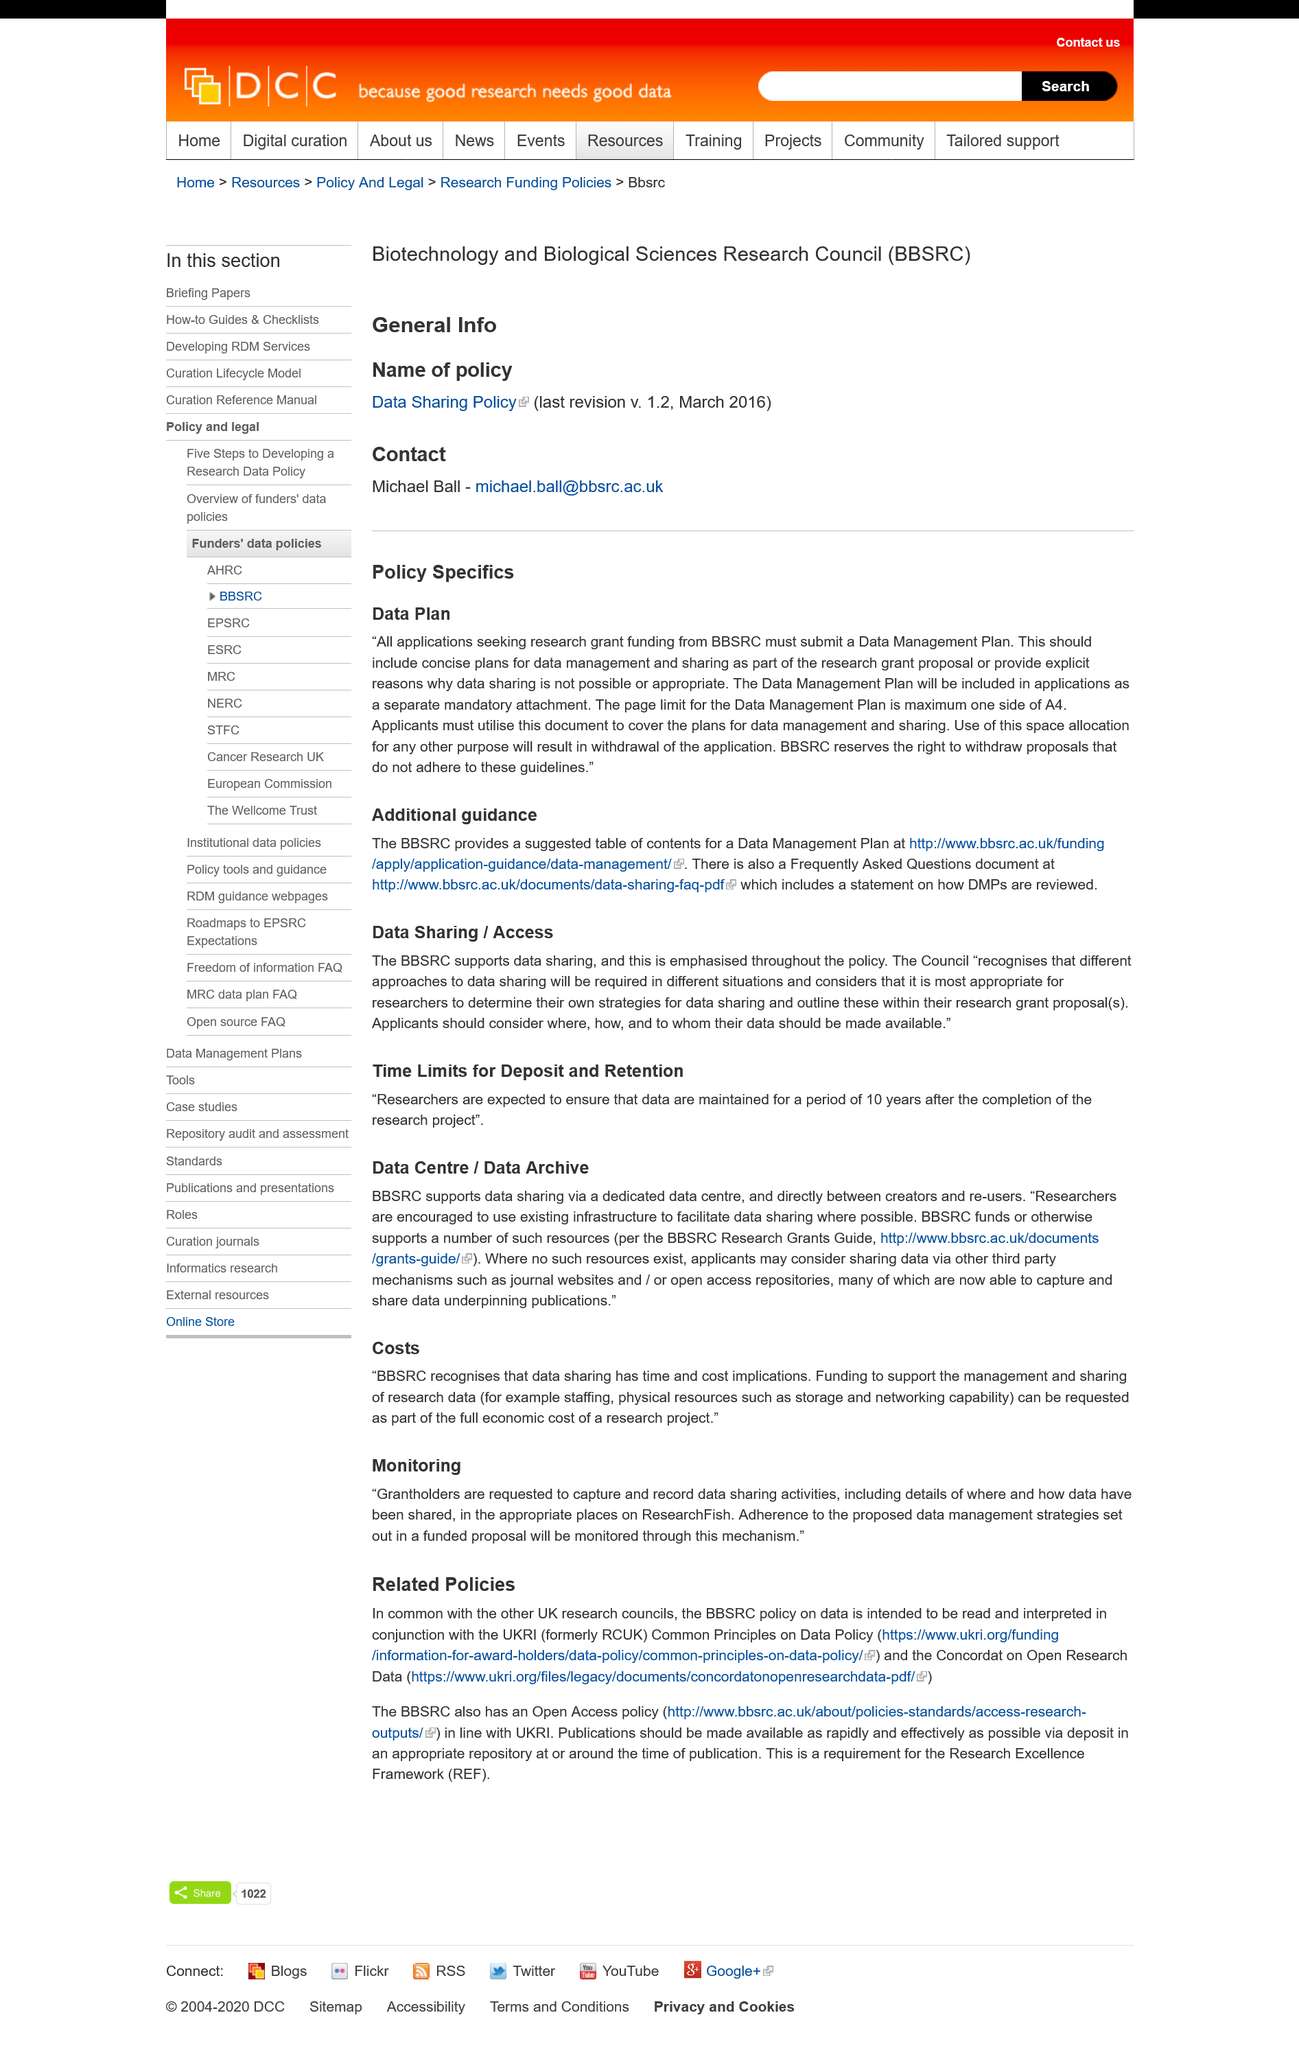Specify some key components in this picture. The BBSRC reserves the right to withdraw proposals that do not adhere to the guidelines. The maximum page limit for the Data Management Plan is one side of A4. Yes, there is a Frequently Asked Questions document available under 'Additional Guidance' that provides answers to commonly asked questions regarding a particular topic. 